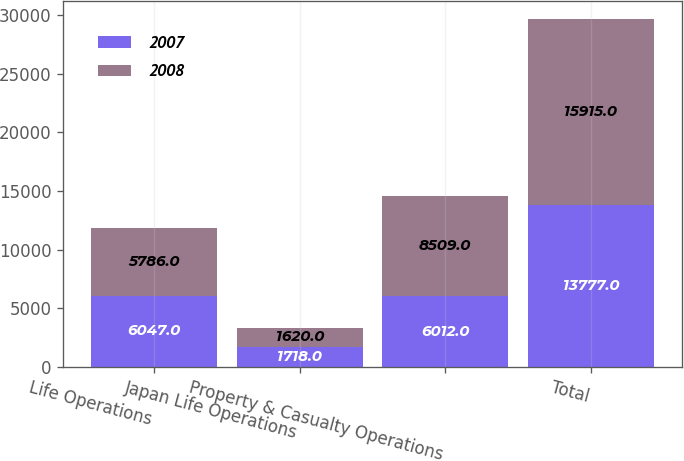Convert chart to OTSL. <chart><loc_0><loc_0><loc_500><loc_500><stacked_bar_chart><ecel><fcel>Life Operations<fcel>Japan Life Operations<fcel>Property & Casualty Operations<fcel>Total<nl><fcel>2007<fcel>6047<fcel>1718<fcel>6012<fcel>13777<nl><fcel>2008<fcel>5786<fcel>1620<fcel>8509<fcel>15915<nl></chart> 